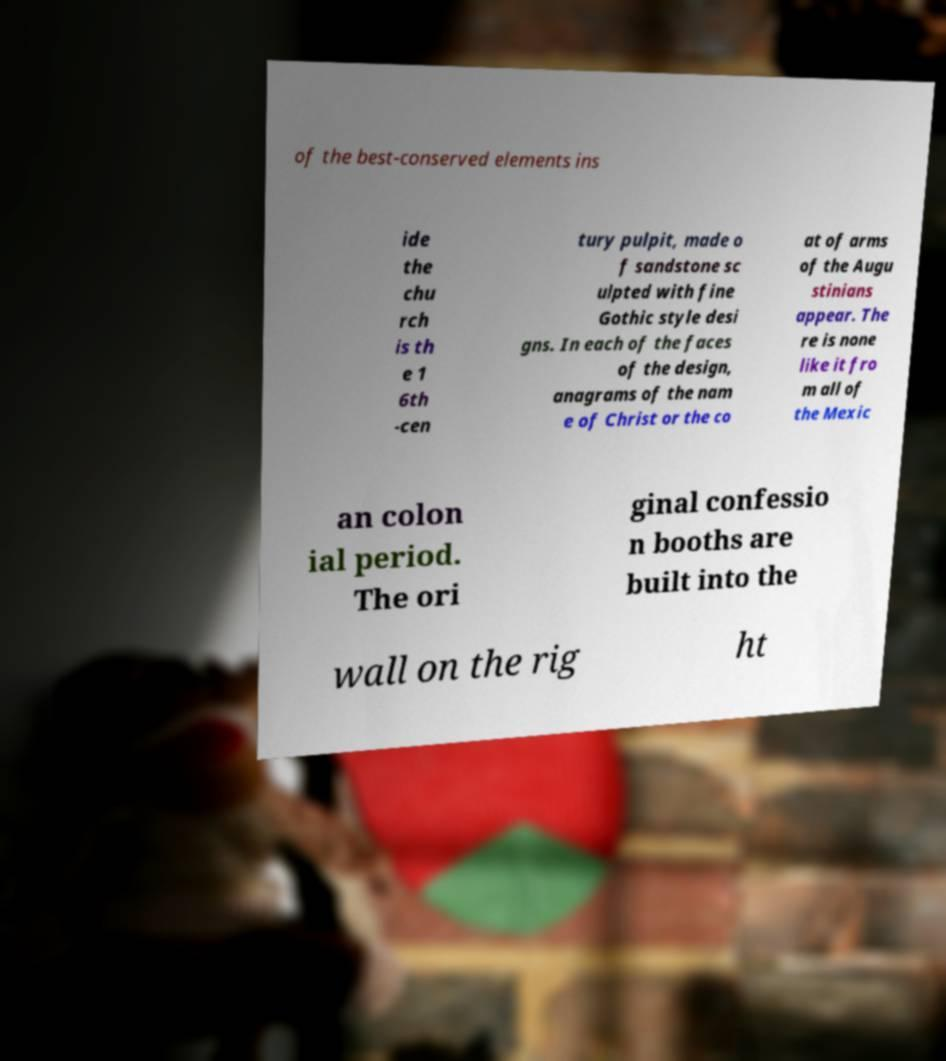There's text embedded in this image that I need extracted. Can you transcribe it verbatim? of the best-conserved elements ins ide the chu rch is th e 1 6th -cen tury pulpit, made o f sandstone sc ulpted with fine Gothic style desi gns. In each of the faces of the design, anagrams of the nam e of Christ or the co at of arms of the Augu stinians appear. The re is none like it fro m all of the Mexic an colon ial period. The ori ginal confessio n booths are built into the wall on the rig ht 